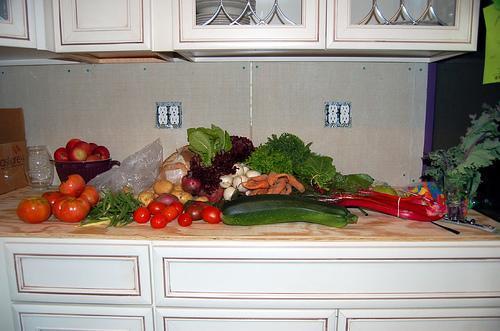How many people are visible?
Give a very brief answer. 0. How many sockets are shown?
Give a very brief answer. 4. How many cabinet handles can you see?
Give a very brief answer. 0. 